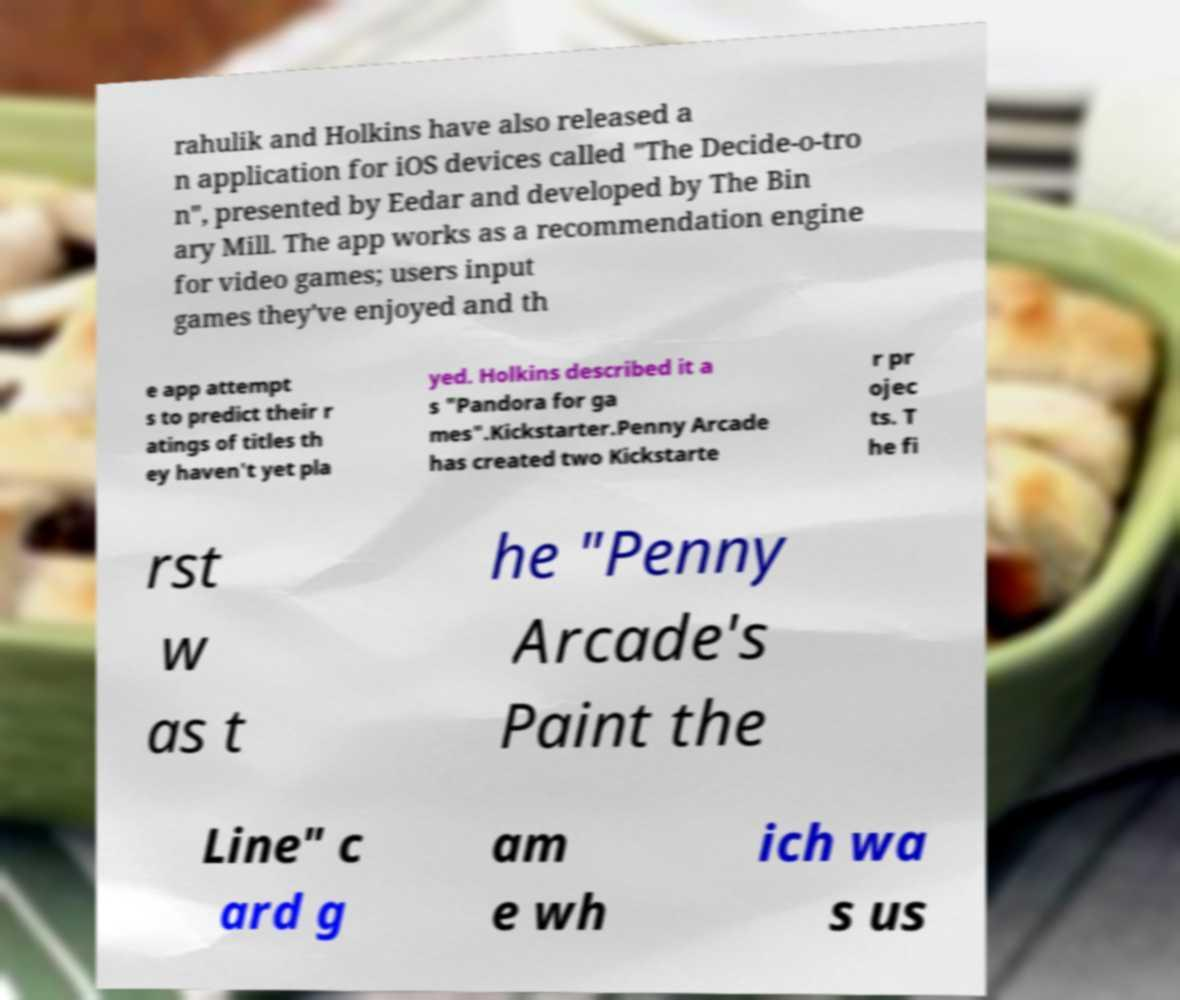What messages or text are displayed in this image? I need them in a readable, typed format. rahulik and Holkins have also released a n application for iOS devices called "The Decide-o-tro n", presented by Eedar and developed by The Bin ary Mill. The app works as a recommendation engine for video games; users input games they've enjoyed and th e app attempt s to predict their r atings of titles th ey haven't yet pla yed. Holkins described it a s "Pandora for ga mes".Kickstarter.Penny Arcade has created two Kickstarte r pr ojec ts. T he fi rst w as t he "Penny Arcade's Paint the Line" c ard g am e wh ich wa s us 